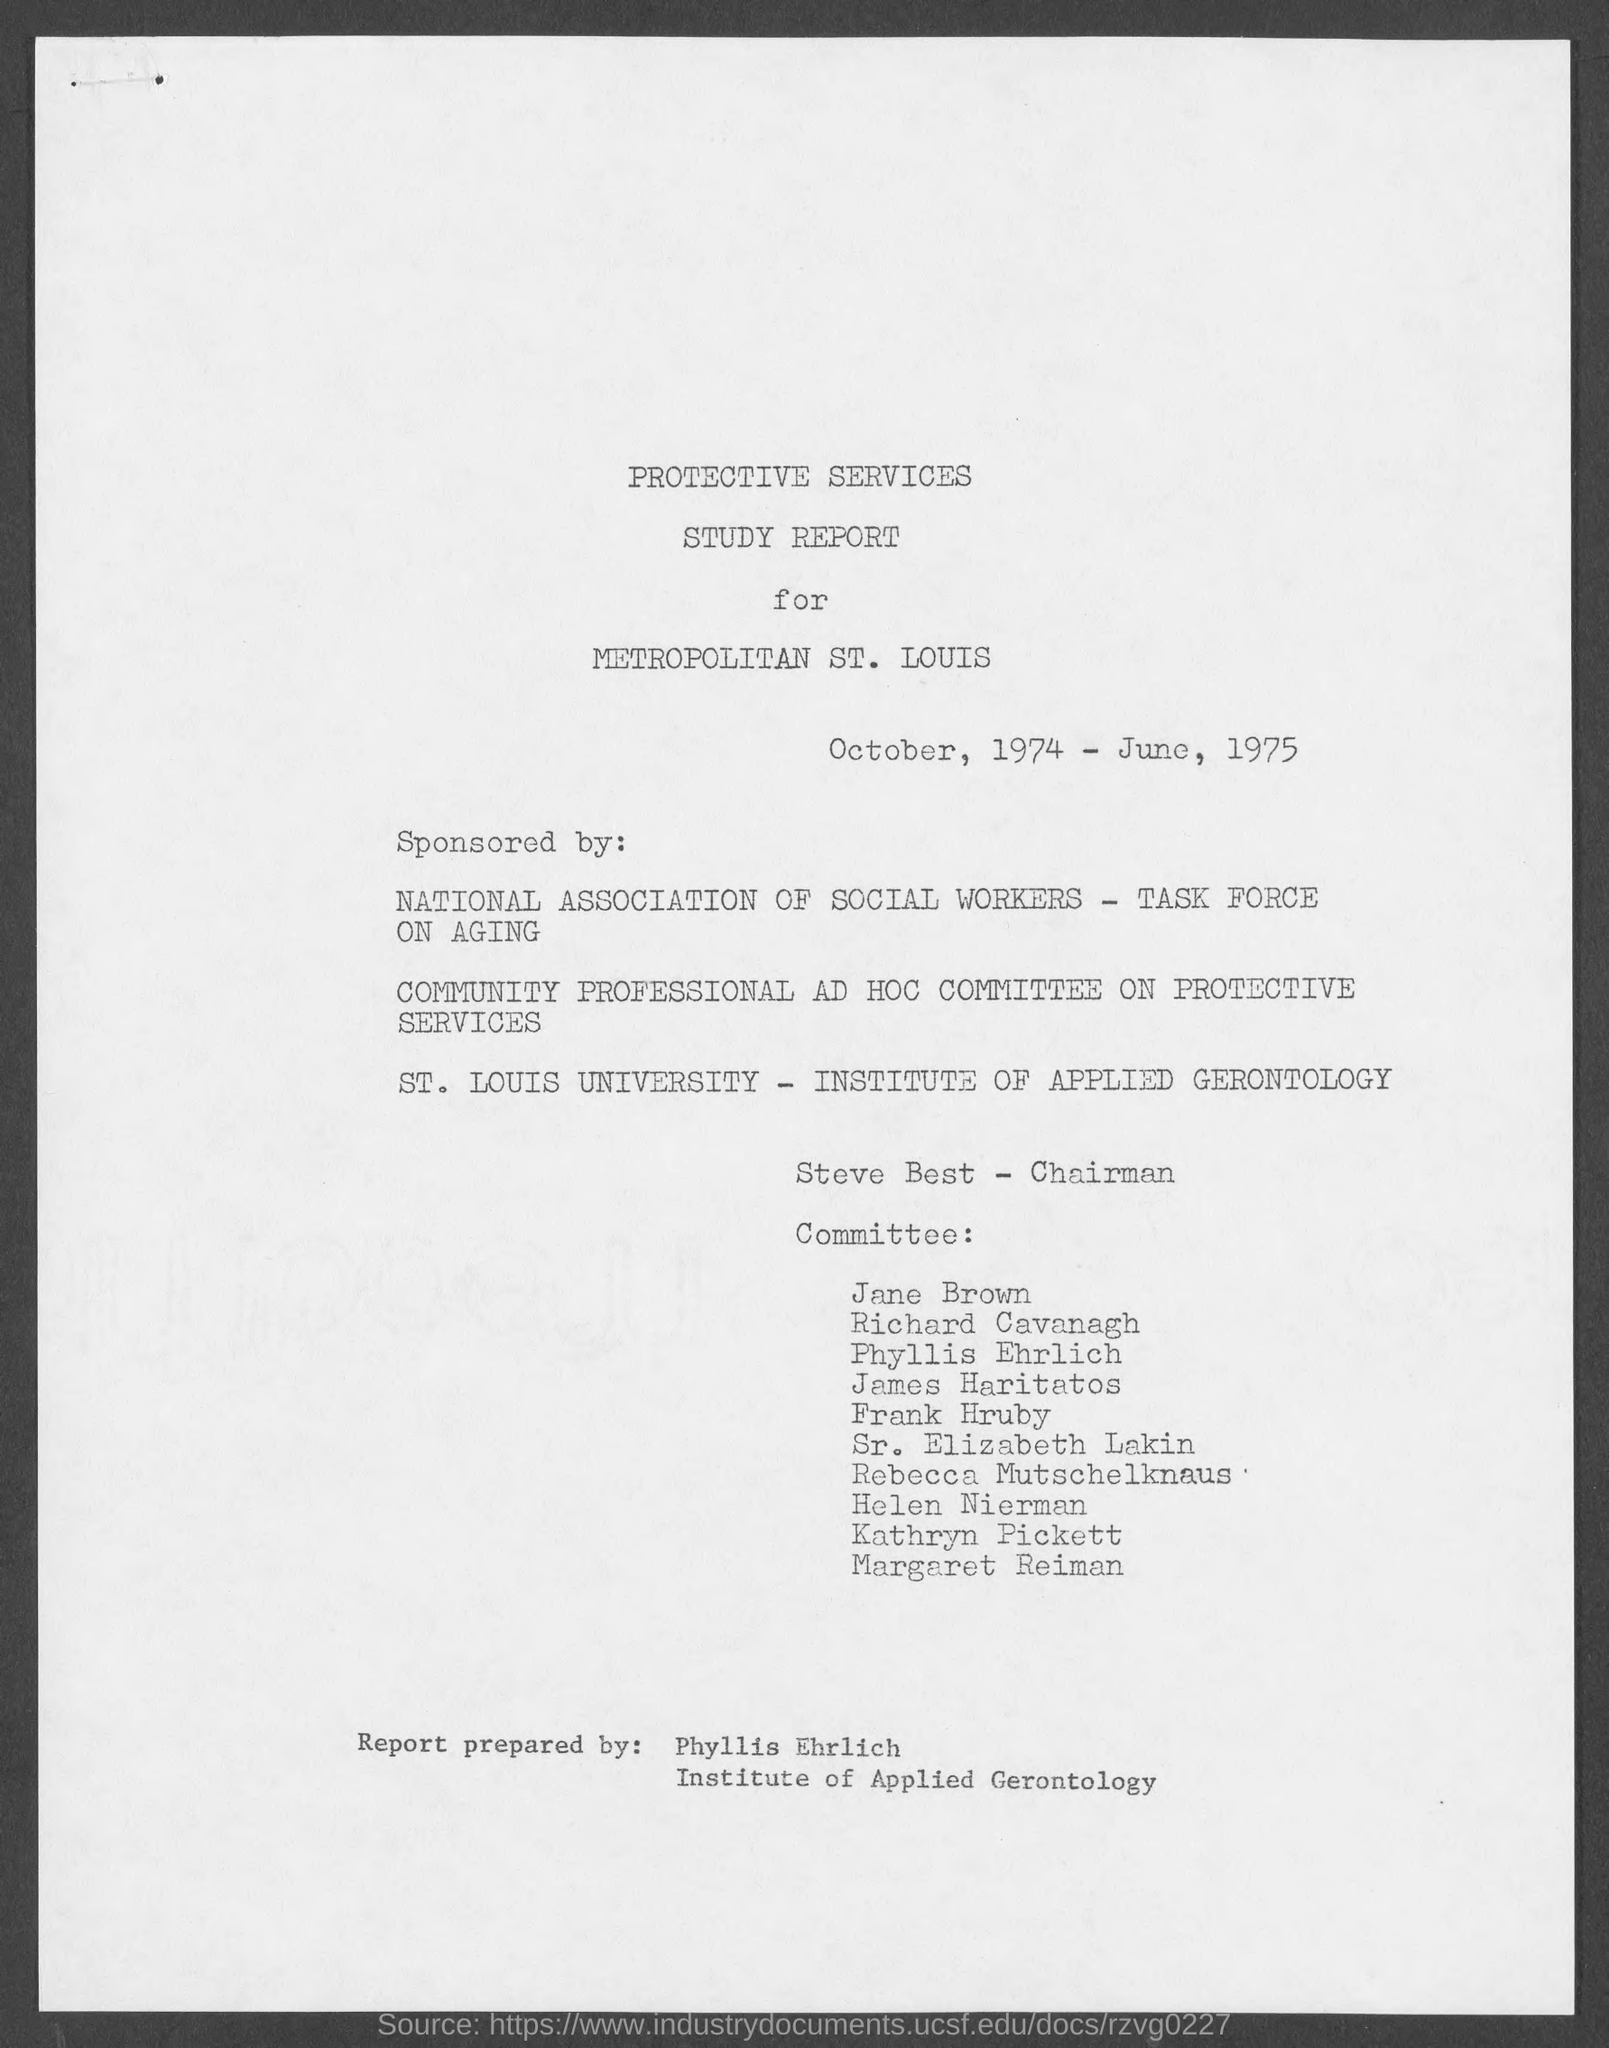Who prepared this report ?
Provide a short and direct response. Phyllis ehrlich. Who is the chairman in report ?
Your answer should be compact. Steve best. 